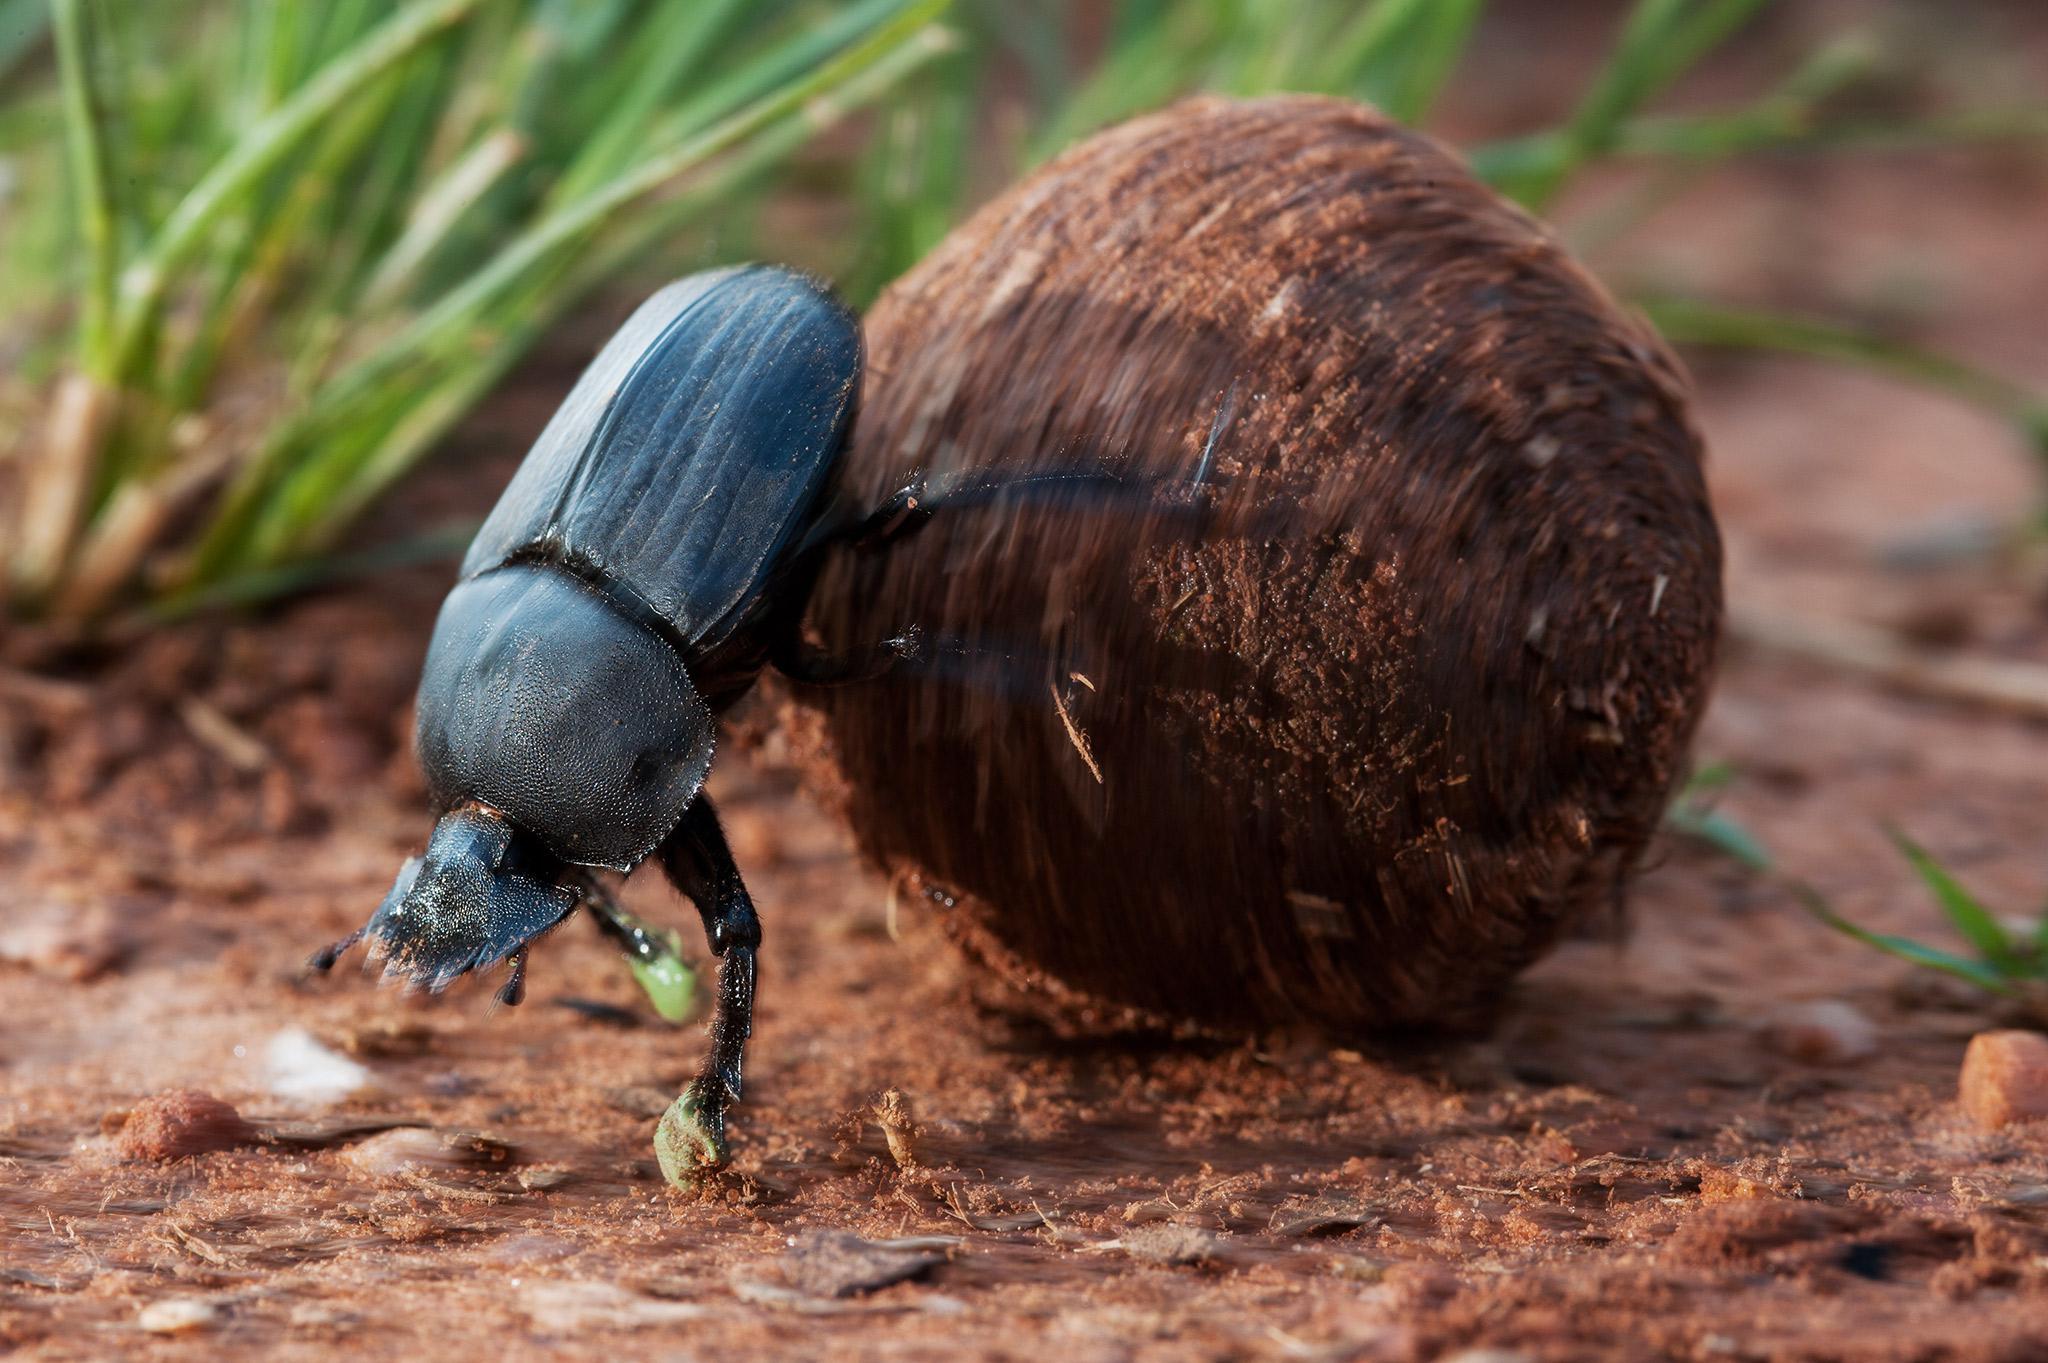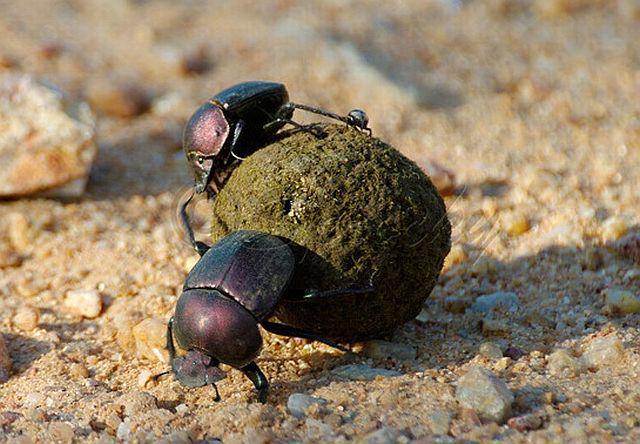The first image is the image on the left, the second image is the image on the right. Assess this claim about the two images: "Left image shows one left-facing beetle with no dungball.". Correct or not? Answer yes or no. No. The first image is the image on the left, the second image is the image on the right. Considering the images on both sides, is "There are two insects touching the ball in the image on the right" valid? Answer yes or no. Yes. 